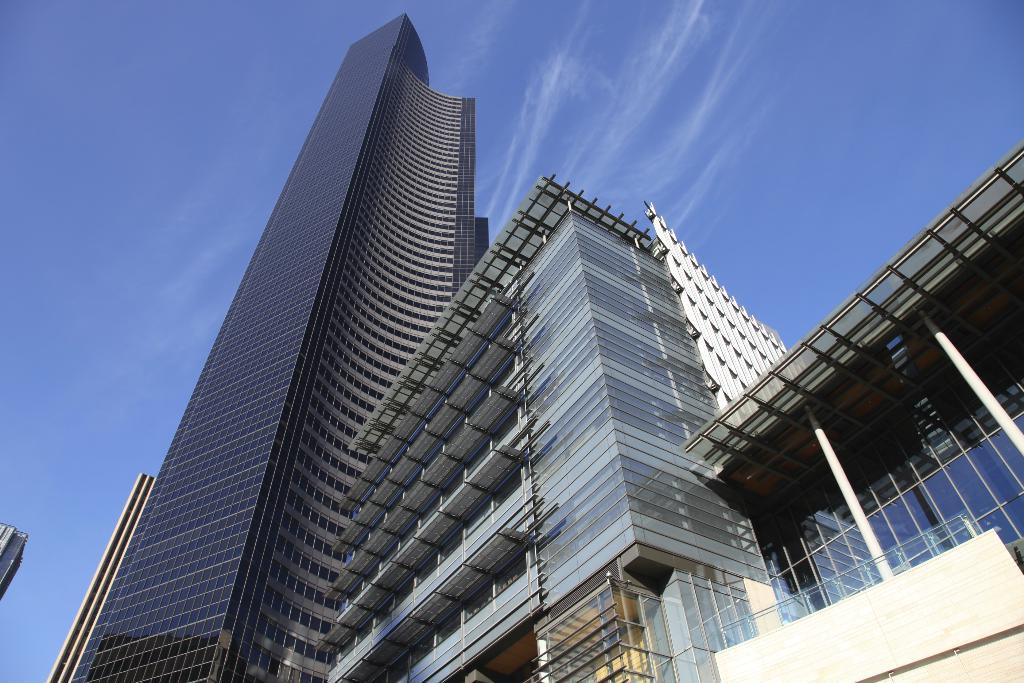What type of structures are present in the image? There are buildings with windows in the image. What can be seen above the buildings in the image? The sky is visible in the image. How would you describe the appearance of the sky in the image? The sky appears to be cloudy in the image. What type of shade does the building provide in the image? There is no mention of a shade or any specific area being shaded by the building in the image. 